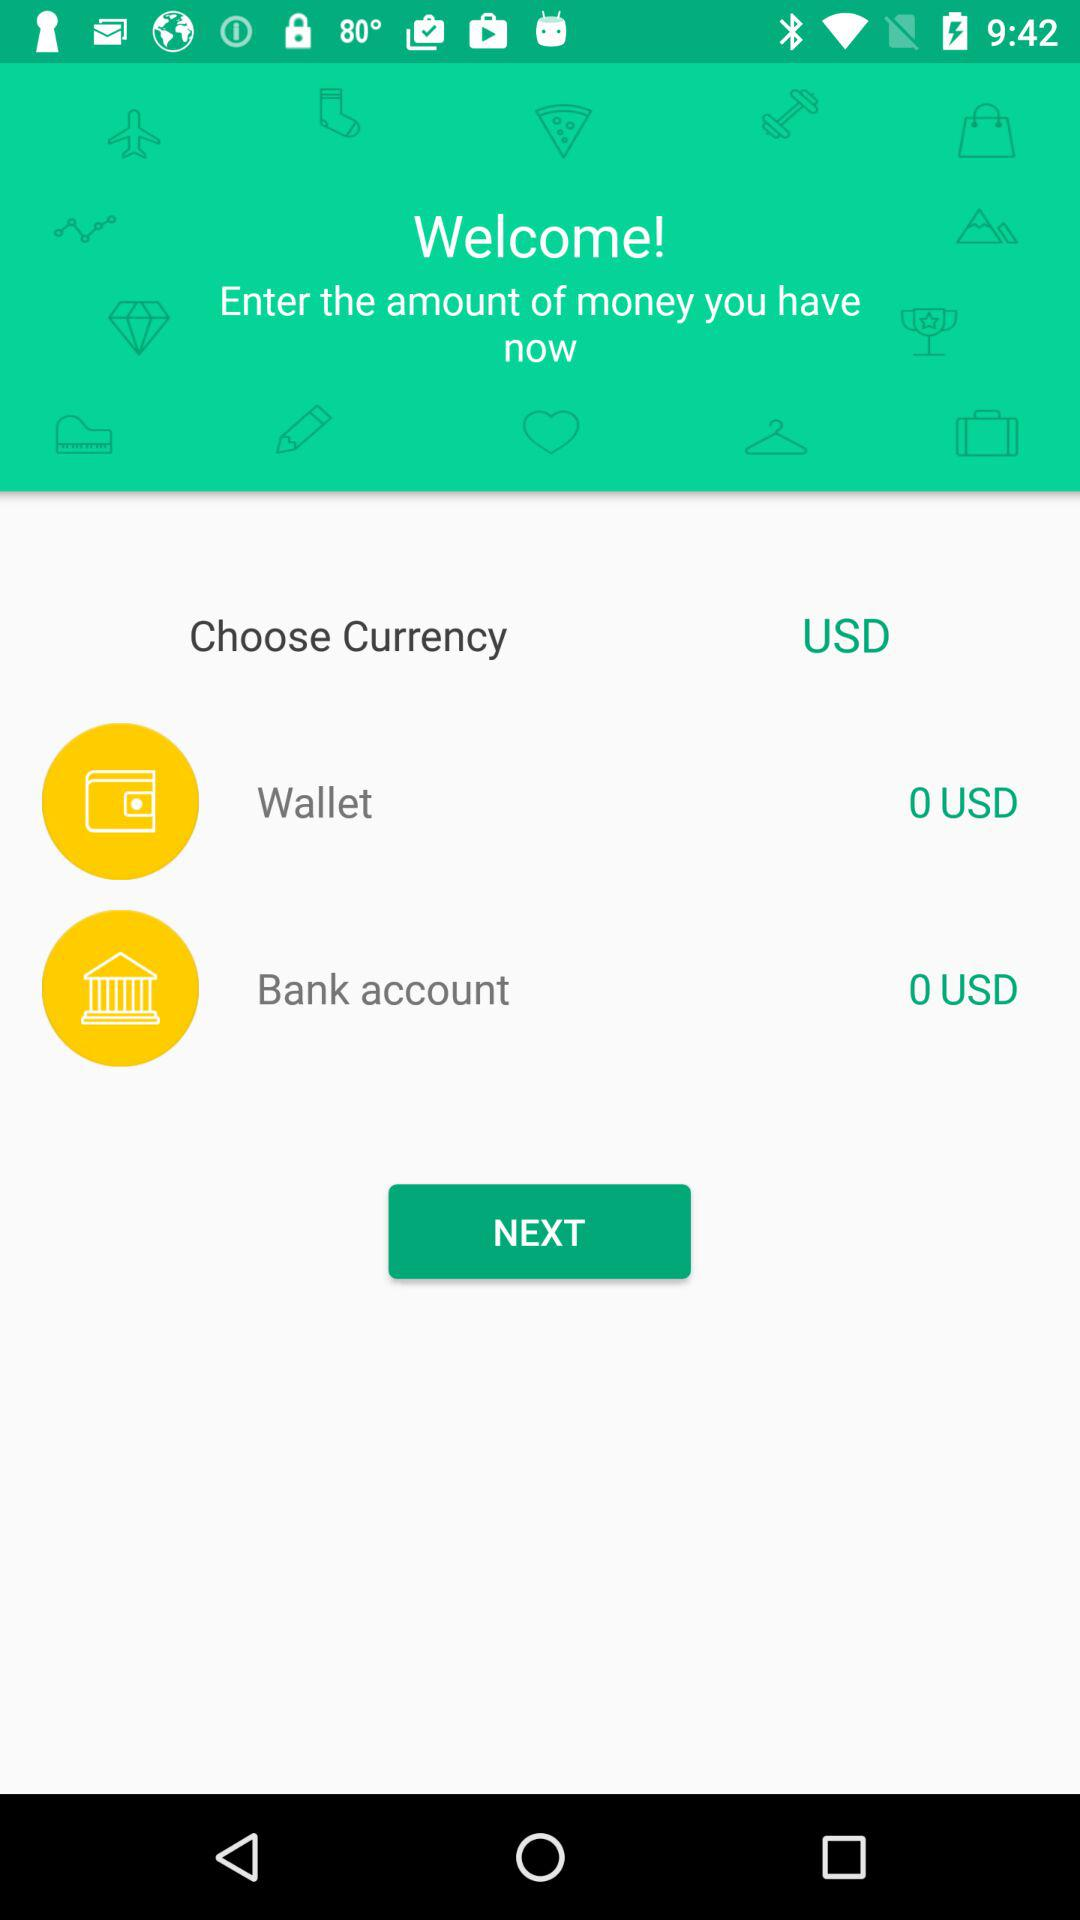How much money do I have in my wallet?
Answer the question using a single word or phrase. 0 USD 